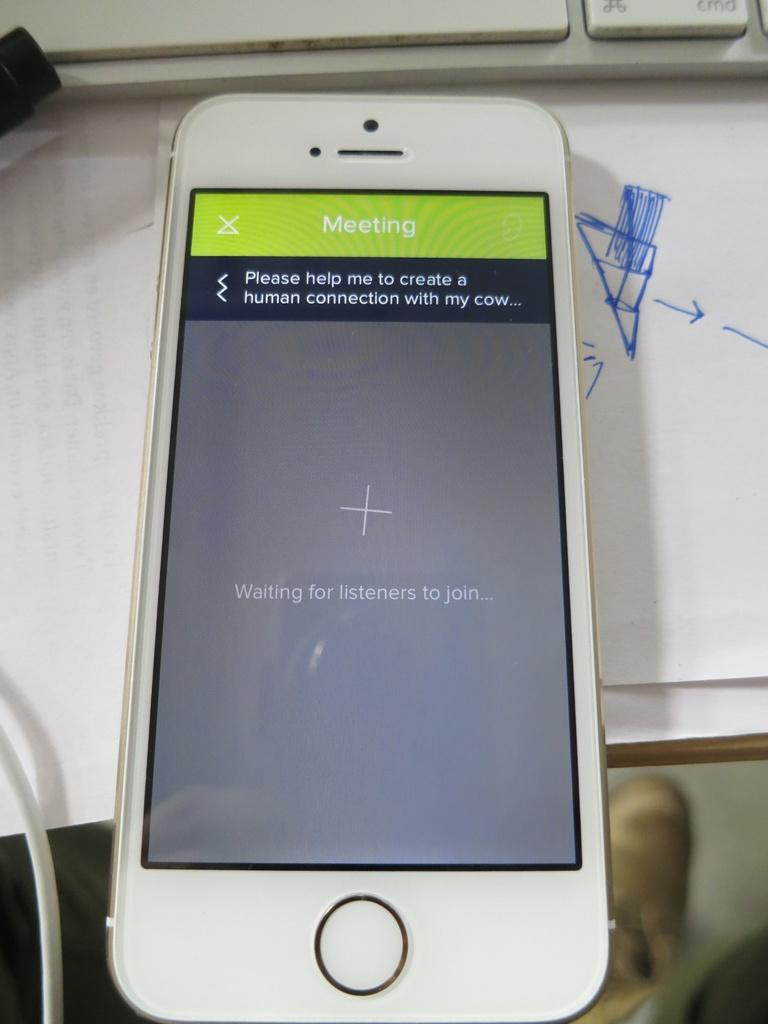<image>
Give a short and clear explanation of the subsequent image. A cell phone reads Waiting for listeners to join on the screen. 